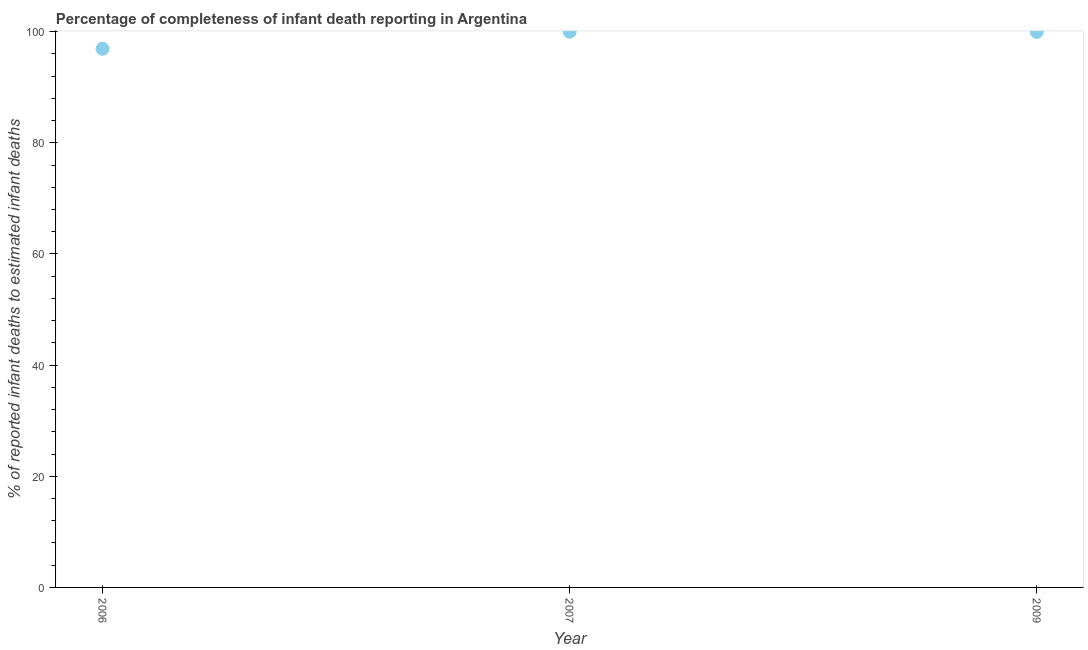What is the completeness of infant death reporting in 2009?
Your answer should be very brief. 99.97. Across all years, what is the minimum completeness of infant death reporting?
Ensure brevity in your answer.  96.93. What is the sum of the completeness of infant death reporting?
Keep it short and to the point. 296.89. What is the difference between the completeness of infant death reporting in 2007 and 2009?
Provide a short and direct response. 0.03. What is the average completeness of infant death reporting per year?
Offer a terse response. 98.96. What is the median completeness of infant death reporting?
Give a very brief answer. 99.97. Do a majority of the years between 2009 and 2007 (inclusive) have completeness of infant death reporting greater than 92 %?
Keep it short and to the point. No. What is the ratio of the completeness of infant death reporting in 2006 to that in 2009?
Your response must be concise. 0.97. Is the completeness of infant death reporting in 2006 less than that in 2007?
Provide a short and direct response. Yes. What is the difference between the highest and the second highest completeness of infant death reporting?
Ensure brevity in your answer.  0.03. Is the sum of the completeness of infant death reporting in 2006 and 2007 greater than the maximum completeness of infant death reporting across all years?
Your answer should be very brief. Yes. What is the difference between the highest and the lowest completeness of infant death reporting?
Your response must be concise. 3.07. How many years are there in the graph?
Give a very brief answer. 3. What is the difference between two consecutive major ticks on the Y-axis?
Offer a terse response. 20. Does the graph contain grids?
Your answer should be very brief. No. What is the title of the graph?
Keep it short and to the point. Percentage of completeness of infant death reporting in Argentina. What is the label or title of the Y-axis?
Make the answer very short. % of reported infant deaths to estimated infant deaths. What is the % of reported infant deaths to estimated infant deaths in 2006?
Offer a terse response. 96.93. What is the % of reported infant deaths to estimated infant deaths in 2009?
Give a very brief answer. 99.97. What is the difference between the % of reported infant deaths to estimated infant deaths in 2006 and 2007?
Provide a succinct answer. -3.07. What is the difference between the % of reported infant deaths to estimated infant deaths in 2006 and 2009?
Your answer should be very brief. -3.04. What is the difference between the % of reported infant deaths to estimated infant deaths in 2007 and 2009?
Provide a short and direct response. 0.03. What is the ratio of the % of reported infant deaths to estimated infant deaths in 2006 to that in 2009?
Ensure brevity in your answer.  0.97. 